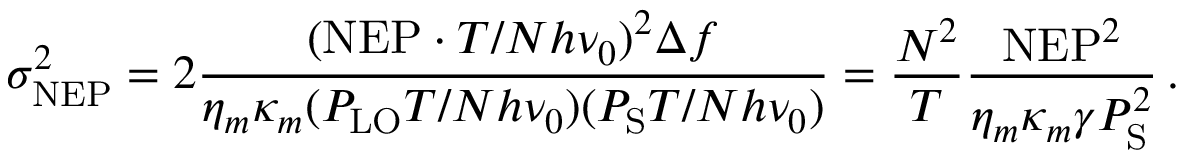Convert formula to latex. <formula><loc_0><loc_0><loc_500><loc_500>\sigma _ { N E P } ^ { 2 } = 2 \frac { ( N E P \cdot T / N h \nu _ { 0 } ) ^ { 2 } \Delta f } { \eta _ { m } \kappa _ { m } ( P _ { L O } T / N h \nu _ { 0 } ) ( P _ { S } T / N h \nu _ { 0 } ) } = \frac { N ^ { 2 } } { T } \frac { N E P ^ { 2 } } { \eta _ { m } \kappa _ { m } \gamma P _ { S } ^ { 2 } } \, .</formula> 